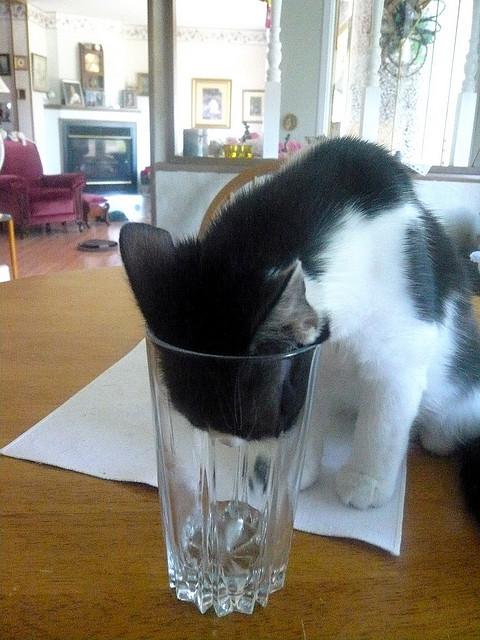Where is the cat's head?
Answer briefly. In glass. What is the cat standing on?
Give a very brief answer. Table. Is it nighttime?
Concise answer only. No. 